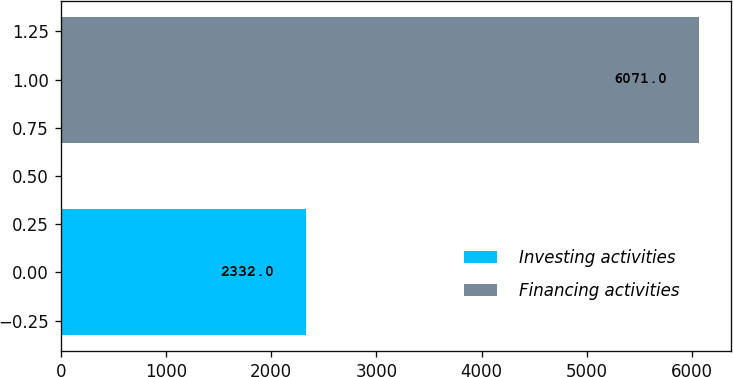Convert chart. <chart><loc_0><loc_0><loc_500><loc_500><bar_chart><fcel>Investing activities<fcel>Financing activities<nl><fcel>2332<fcel>6071<nl></chart> 